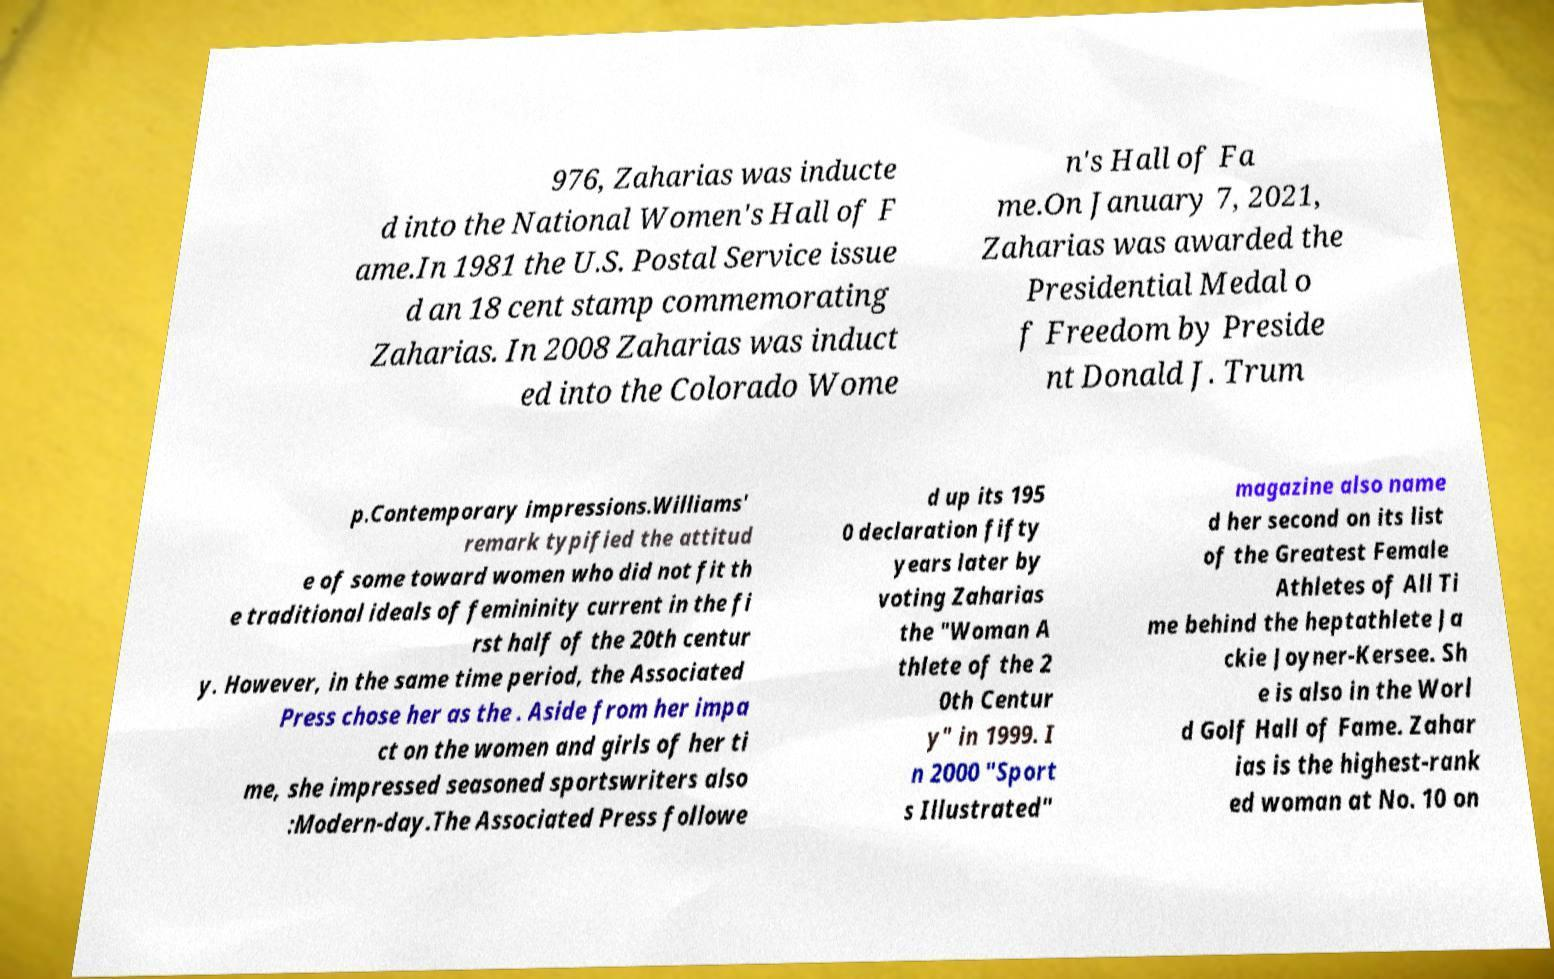Please read and relay the text visible in this image. What does it say? 976, Zaharias was inducte d into the National Women's Hall of F ame.In 1981 the U.S. Postal Service issue d an 18 cent stamp commemorating Zaharias. In 2008 Zaharias was induct ed into the Colorado Wome n's Hall of Fa me.On January 7, 2021, Zaharias was awarded the Presidential Medal o f Freedom by Preside nt Donald J. Trum p.Contemporary impressions.Williams' remark typified the attitud e of some toward women who did not fit th e traditional ideals of femininity current in the fi rst half of the 20th centur y. However, in the same time period, the Associated Press chose her as the . Aside from her impa ct on the women and girls of her ti me, she impressed seasoned sportswriters also :Modern-day.The Associated Press followe d up its 195 0 declaration fifty years later by voting Zaharias the "Woman A thlete of the 2 0th Centur y" in 1999. I n 2000 "Sport s Illustrated" magazine also name d her second on its list of the Greatest Female Athletes of All Ti me behind the heptathlete Ja ckie Joyner-Kersee. Sh e is also in the Worl d Golf Hall of Fame. Zahar ias is the highest-rank ed woman at No. 10 on 